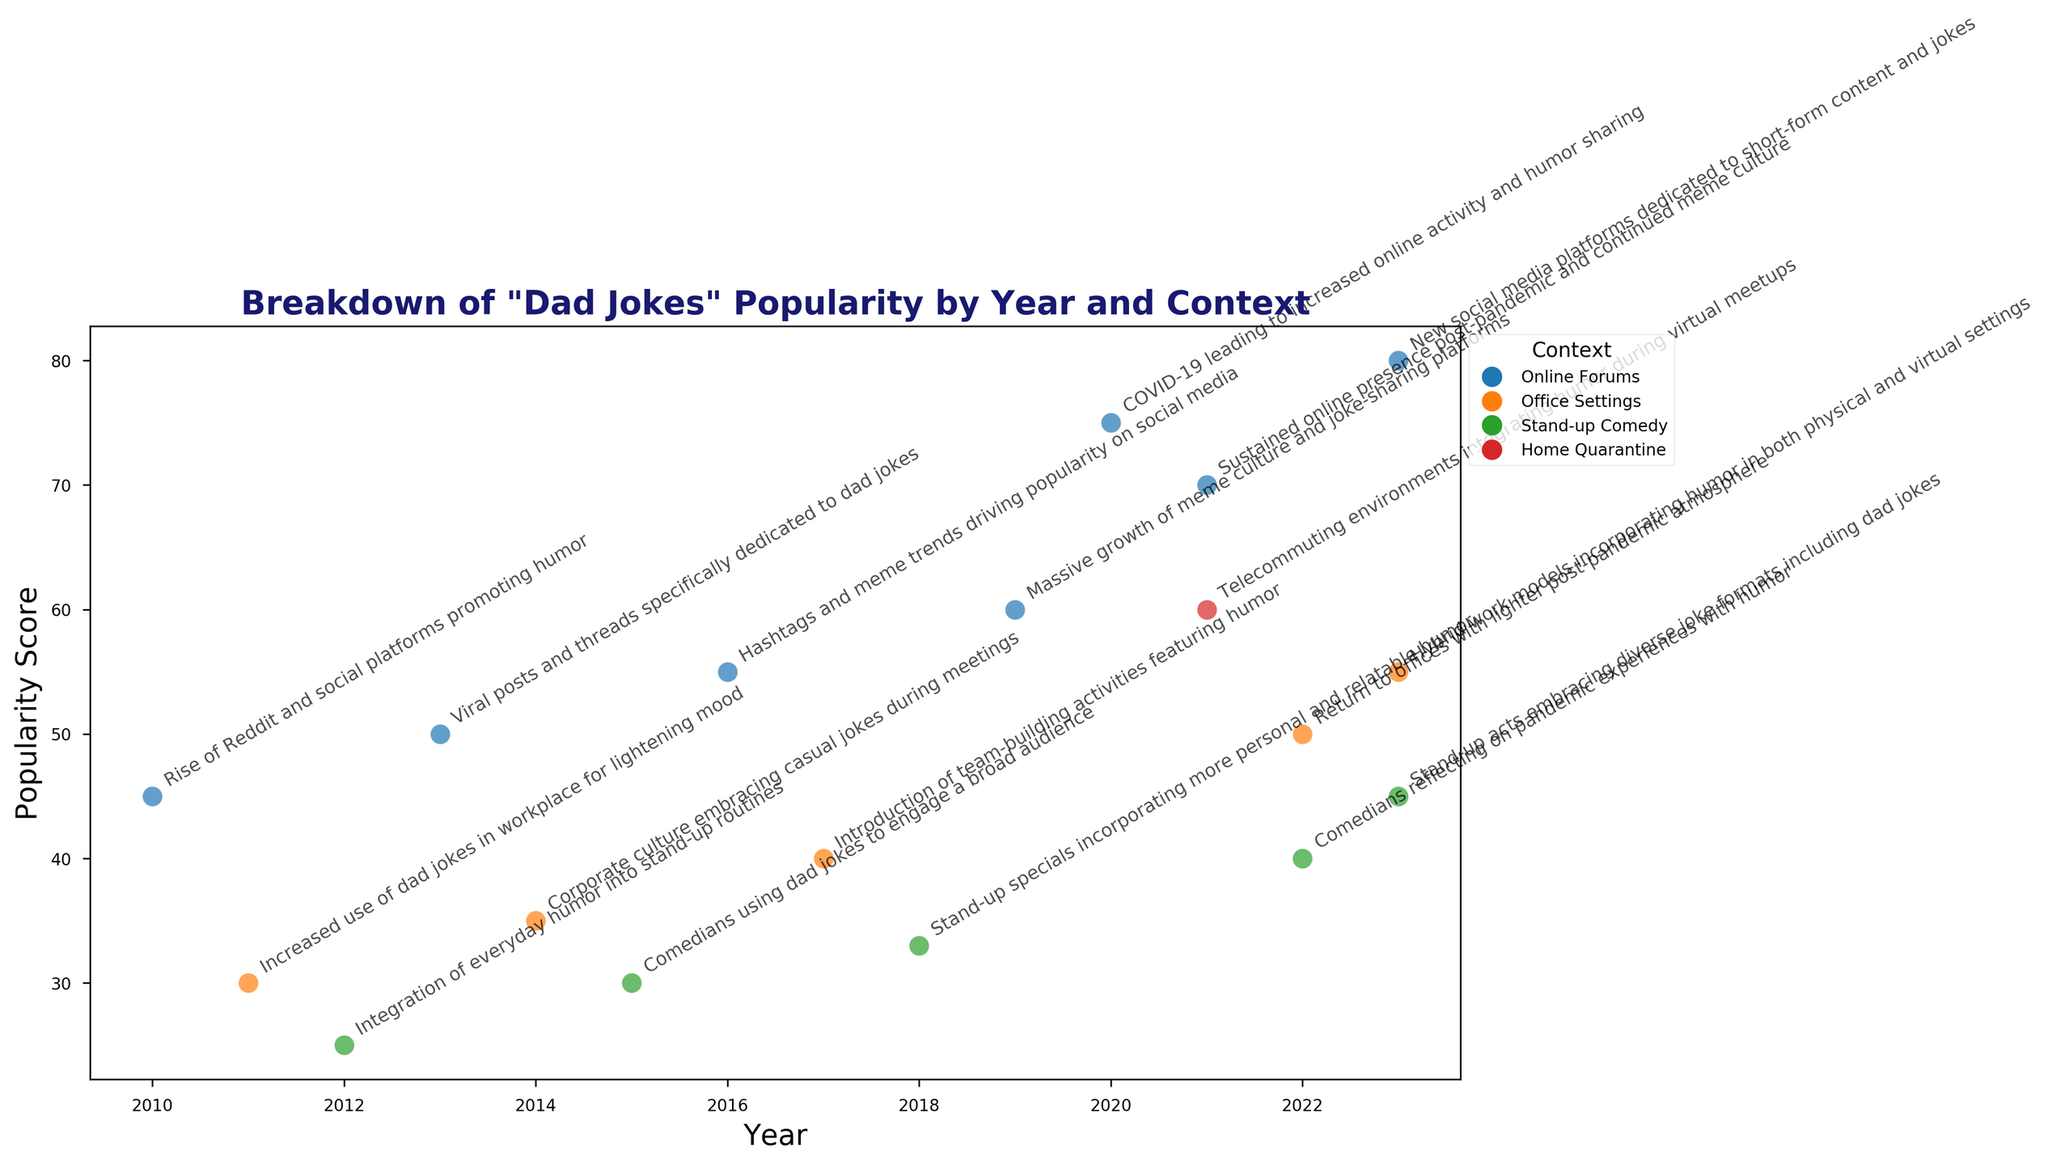1. Which context had the highest popularity score in 2020? First, locate the year 2020 on the x-axis. The highest point in 2020 on the y-axis corresponds to 'Online Forums' with a popularity score of 75.
Answer: Online Forums 2. How did the popularity score for 'Stand-up Comedy' change from 2015 to 2023? In 2015, the popularity score for 'Stand-up Comedy' was 30. In 2023, the score was 45. The change is calculated as 45 - 30 = 15.
Answer: Increased by 15 3. What is the total popularity score for 'Office Settings' in 2023? In 2023, the popularity score for 'Office Settings' was 55. This is the value at the data point for 'Office Settings' in 2023.
Answer: 55 4. Among 'Online Forums', 'Office Settings', and 'Stand-up Comedy', which context saw the largest single-year increase in popularity score? Compare each context's greatest year-to-year changes: 'Online Forums' increased from 60 in 2019 to 75 in 2020, a difference of 15. 'Office Settings' and 'Stand-up Comedy' did not have a larger single-year increase.
Answer: Online Forums 5. What is the average popularity score for all contexts in 2021? For 2021, the popularity scores are 70 for Online Forums and 60 for Home Quarantine. The average is (70 + 60) / 2 = 65.
Answer: 65 6. In which year did 'Office Settings' and 'Stand-up Comedy' have the same popularity score? From the figure, 'Office Settings' and 'Stand-up Comedy' both had a popularity score of 30 in 2011 and 2015, respectively.
Answer: 2015 7. How many years did 'Online Forums' have a higher popularity score than 'Stand-up Comedy'? Identify the years where 'Online Forums' scores are higher: 2010, 2013, 2016, 2019, 2020, 2021, and 2023. Count these years.
Answer: 7 years 8. Considering the annotations, what significant event in 2020 contributed to the highest spike in 'Online Forums' popularity score? The cultural annotation for 2020 mentions "COVID-19 leading to increased online activity and humor sharing." This is the significant event associated with the spike.
Answer: COVID-19 pandemic 9. Which context consistently increased its popularity score every year it appeared on the plot? From the figure, 'Online Forums' consistently increased each year it appears: 2010 (45), 2013 (50), 2016 (55), 2019 (60), 2020 (75), 2021 (70), 2023 (80).
Answer: Online Forums 10. By how much did the popularity score for 'Office Settings' change from 2011 to 2022? In 2011, the score was 30. In 2022, it was 50. The change is 50 - 30 = 20.
Answer: Increased by 20 